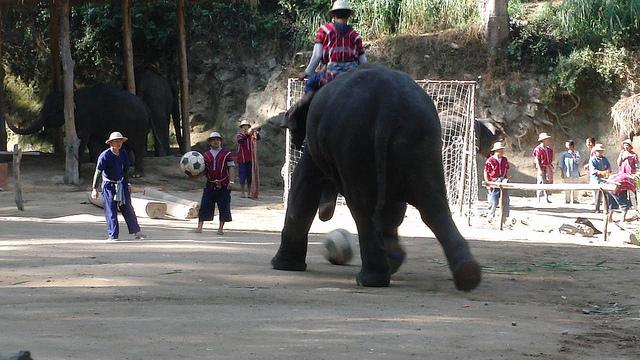What is the elephant doing with the ball? kicking 